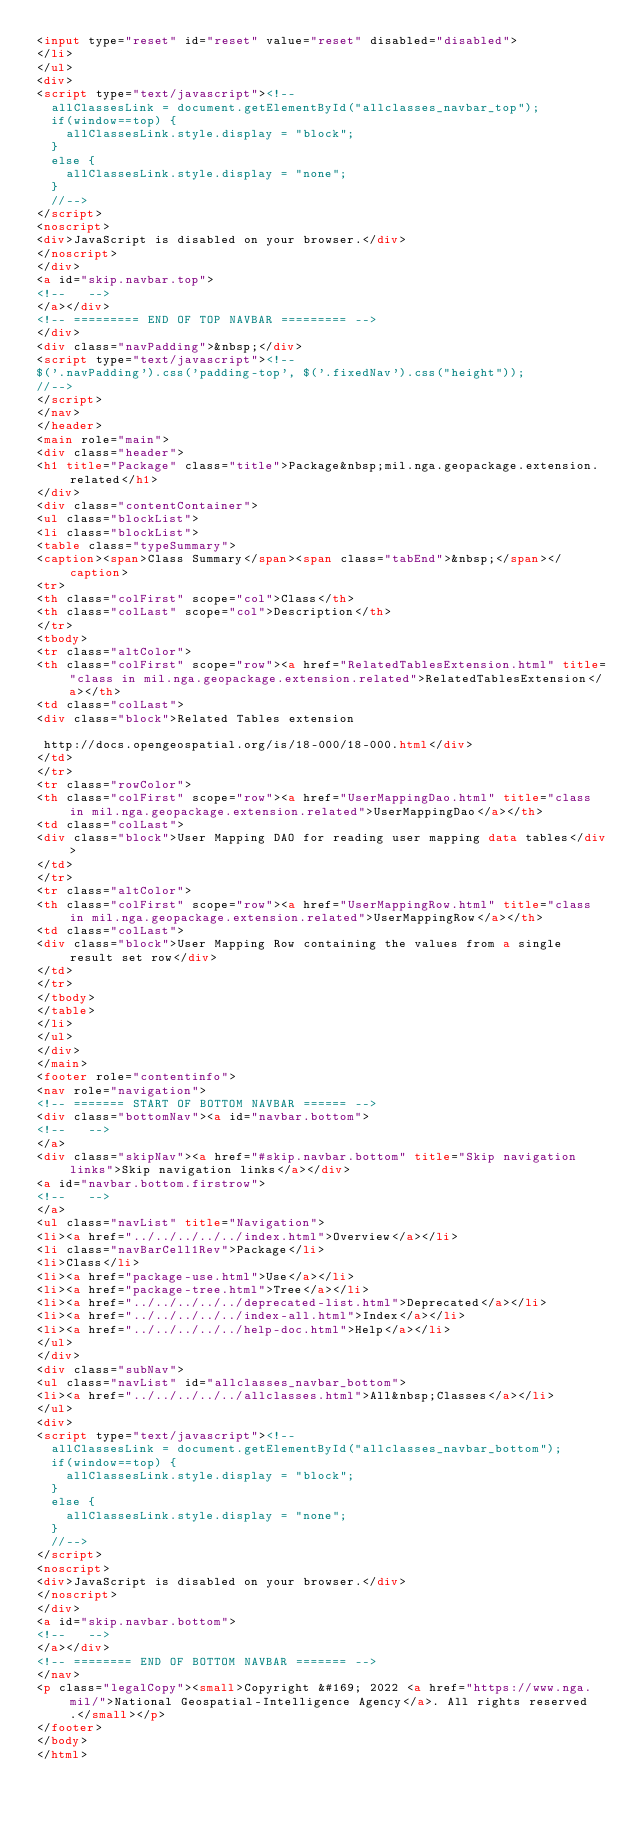Convert code to text. <code><loc_0><loc_0><loc_500><loc_500><_HTML_><input type="reset" id="reset" value="reset" disabled="disabled">
</li>
</ul>
<div>
<script type="text/javascript"><!--
  allClassesLink = document.getElementById("allclasses_navbar_top");
  if(window==top) {
    allClassesLink.style.display = "block";
  }
  else {
    allClassesLink.style.display = "none";
  }
  //-->
</script>
<noscript>
<div>JavaScript is disabled on your browser.</div>
</noscript>
</div>
<a id="skip.navbar.top">
<!--   -->
</a></div>
<!-- ========= END OF TOP NAVBAR ========= -->
</div>
<div class="navPadding">&nbsp;</div>
<script type="text/javascript"><!--
$('.navPadding').css('padding-top', $('.fixedNav').css("height"));
//-->
</script>
</nav>
</header>
<main role="main">
<div class="header">
<h1 title="Package" class="title">Package&nbsp;mil.nga.geopackage.extension.related</h1>
</div>
<div class="contentContainer">
<ul class="blockList">
<li class="blockList">
<table class="typeSummary">
<caption><span>Class Summary</span><span class="tabEnd">&nbsp;</span></caption>
<tr>
<th class="colFirst" scope="col">Class</th>
<th class="colLast" scope="col">Description</th>
</tr>
<tbody>
<tr class="altColor">
<th class="colFirst" scope="row"><a href="RelatedTablesExtension.html" title="class in mil.nga.geopackage.extension.related">RelatedTablesExtension</a></th>
<td class="colLast">
<div class="block">Related Tables extension
 
 http://docs.opengeospatial.org/is/18-000/18-000.html</div>
</td>
</tr>
<tr class="rowColor">
<th class="colFirst" scope="row"><a href="UserMappingDao.html" title="class in mil.nga.geopackage.extension.related">UserMappingDao</a></th>
<td class="colLast">
<div class="block">User Mapping DAO for reading user mapping data tables</div>
</td>
</tr>
<tr class="altColor">
<th class="colFirst" scope="row"><a href="UserMappingRow.html" title="class in mil.nga.geopackage.extension.related">UserMappingRow</a></th>
<td class="colLast">
<div class="block">User Mapping Row containing the values from a single result set row</div>
</td>
</tr>
</tbody>
</table>
</li>
</ul>
</div>
</main>
<footer role="contentinfo">
<nav role="navigation">
<!-- ======= START OF BOTTOM NAVBAR ====== -->
<div class="bottomNav"><a id="navbar.bottom">
<!--   -->
</a>
<div class="skipNav"><a href="#skip.navbar.bottom" title="Skip navigation links">Skip navigation links</a></div>
<a id="navbar.bottom.firstrow">
<!--   -->
</a>
<ul class="navList" title="Navigation">
<li><a href="../../../../../index.html">Overview</a></li>
<li class="navBarCell1Rev">Package</li>
<li>Class</li>
<li><a href="package-use.html">Use</a></li>
<li><a href="package-tree.html">Tree</a></li>
<li><a href="../../../../../deprecated-list.html">Deprecated</a></li>
<li><a href="../../../../../index-all.html">Index</a></li>
<li><a href="../../../../../help-doc.html">Help</a></li>
</ul>
</div>
<div class="subNav">
<ul class="navList" id="allclasses_navbar_bottom">
<li><a href="../../../../../allclasses.html">All&nbsp;Classes</a></li>
</ul>
<div>
<script type="text/javascript"><!--
  allClassesLink = document.getElementById("allclasses_navbar_bottom");
  if(window==top) {
    allClassesLink.style.display = "block";
  }
  else {
    allClassesLink.style.display = "none";
  }
  //-->
</script>
<noscript>
<div>JavaScript is disabled on your browser.</div>
</noscript>
</div>
<a id="skip.navbar.bottom">
<!--   -->
</a></div>
<!-- ======== END OF BOTTOM NAVBAR ======= -->
</nav>
<p class="legalCopy"><small>Copyright &#169; 2022 <a href="https://www.nga.mil/">National Geospatial-Intelligence Agency</a>. All rights reserved.</small></p>
</footer>
</body>
</html>
</code> 